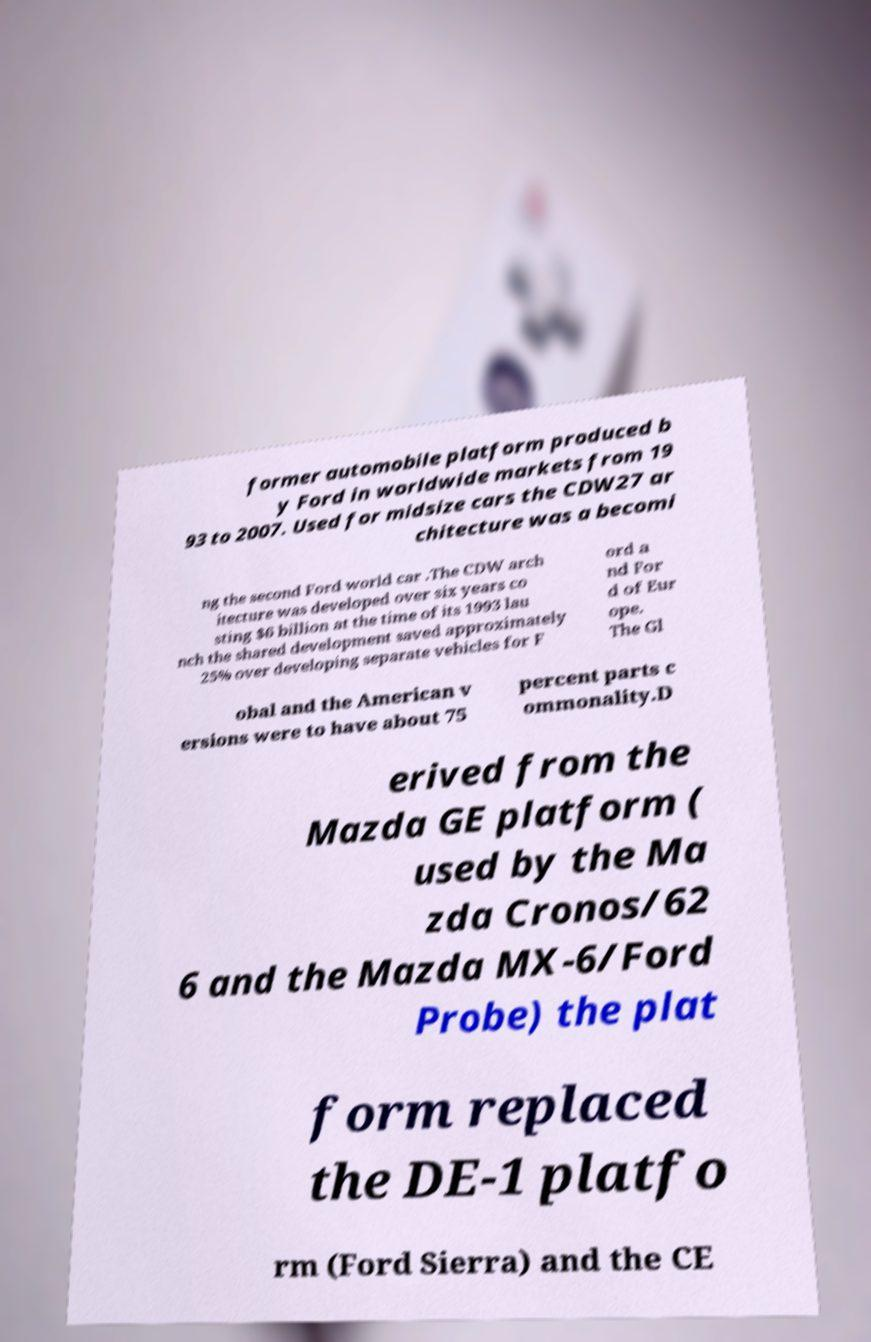For documentation purposes, I need the text within this image transcribed. Could you provide that? former automobile platform produced b y Ford in worldwide markets from 19 93 to 2007. Used for midsize cars the CDW27 ar chitecture was a becomi ng the second Ford world car .The CDW arch itecture was developed over six years co sting $6 billion at the time of its 1993 lau nch the shared development saved approximately 25% over developing separate vehicles for F ord a nd For d of Eur ope. The Gl obal and the American v ersions were to have about 75 percent parts c ommonality.D erived from the Mazda GE platform ( used by the Ma zda Cronos/62 6 and the Mazda MX-6/Ford Probe) the plat form replaced the DE-1 platfo rm (Ford Sierra) and the CE 